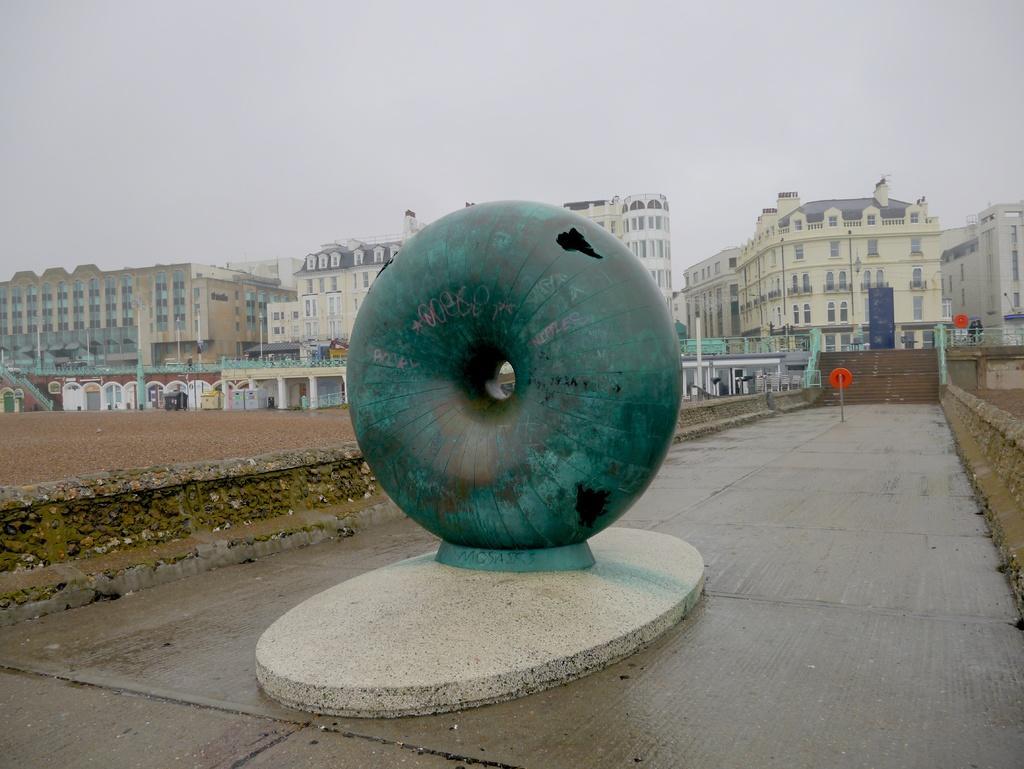In one or two sentences, can you explain what this image depicts? In this image we can see concrete object and we can also see buildings with windows, stairs, railing and sky. 